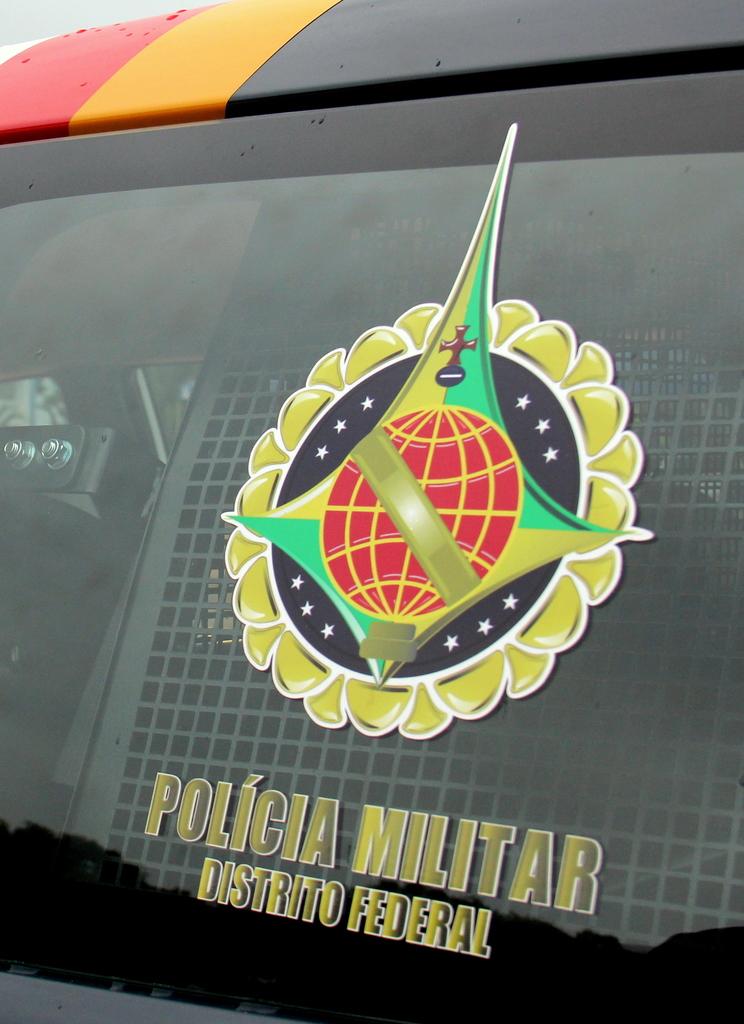What is this place?
Your answer should be very brief. Unanswerable. What is the last word on the bottom line?
Offer a terse response. Federal. 